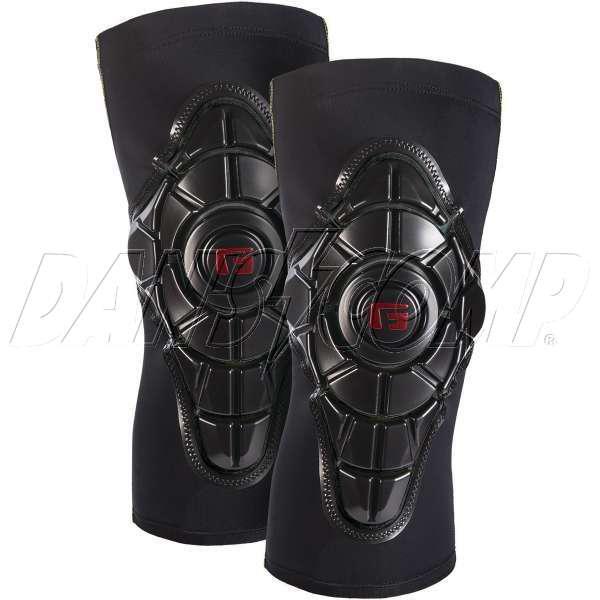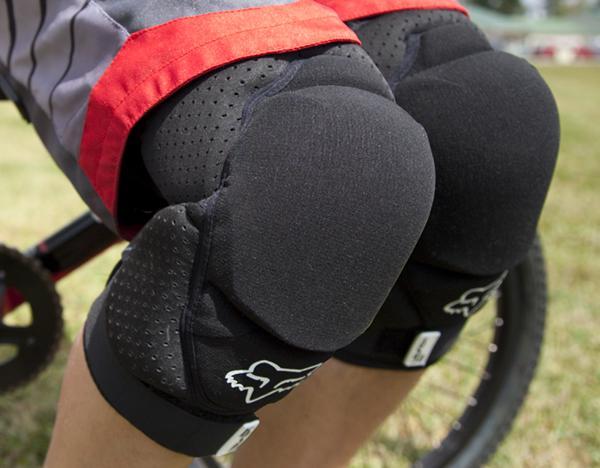The first image is the image on the left, the second image is the image on the right. Given the left and right images, does the statement "One pair of guards is incomplete." hold true? Answer yes or no. No. The first image is the image on the left, the second image is the image on the right. Examine the images to the left and right. Is the description "The left image contains one kneepad, while the right image contains a pair." accurate? Answer yes or no. No. 